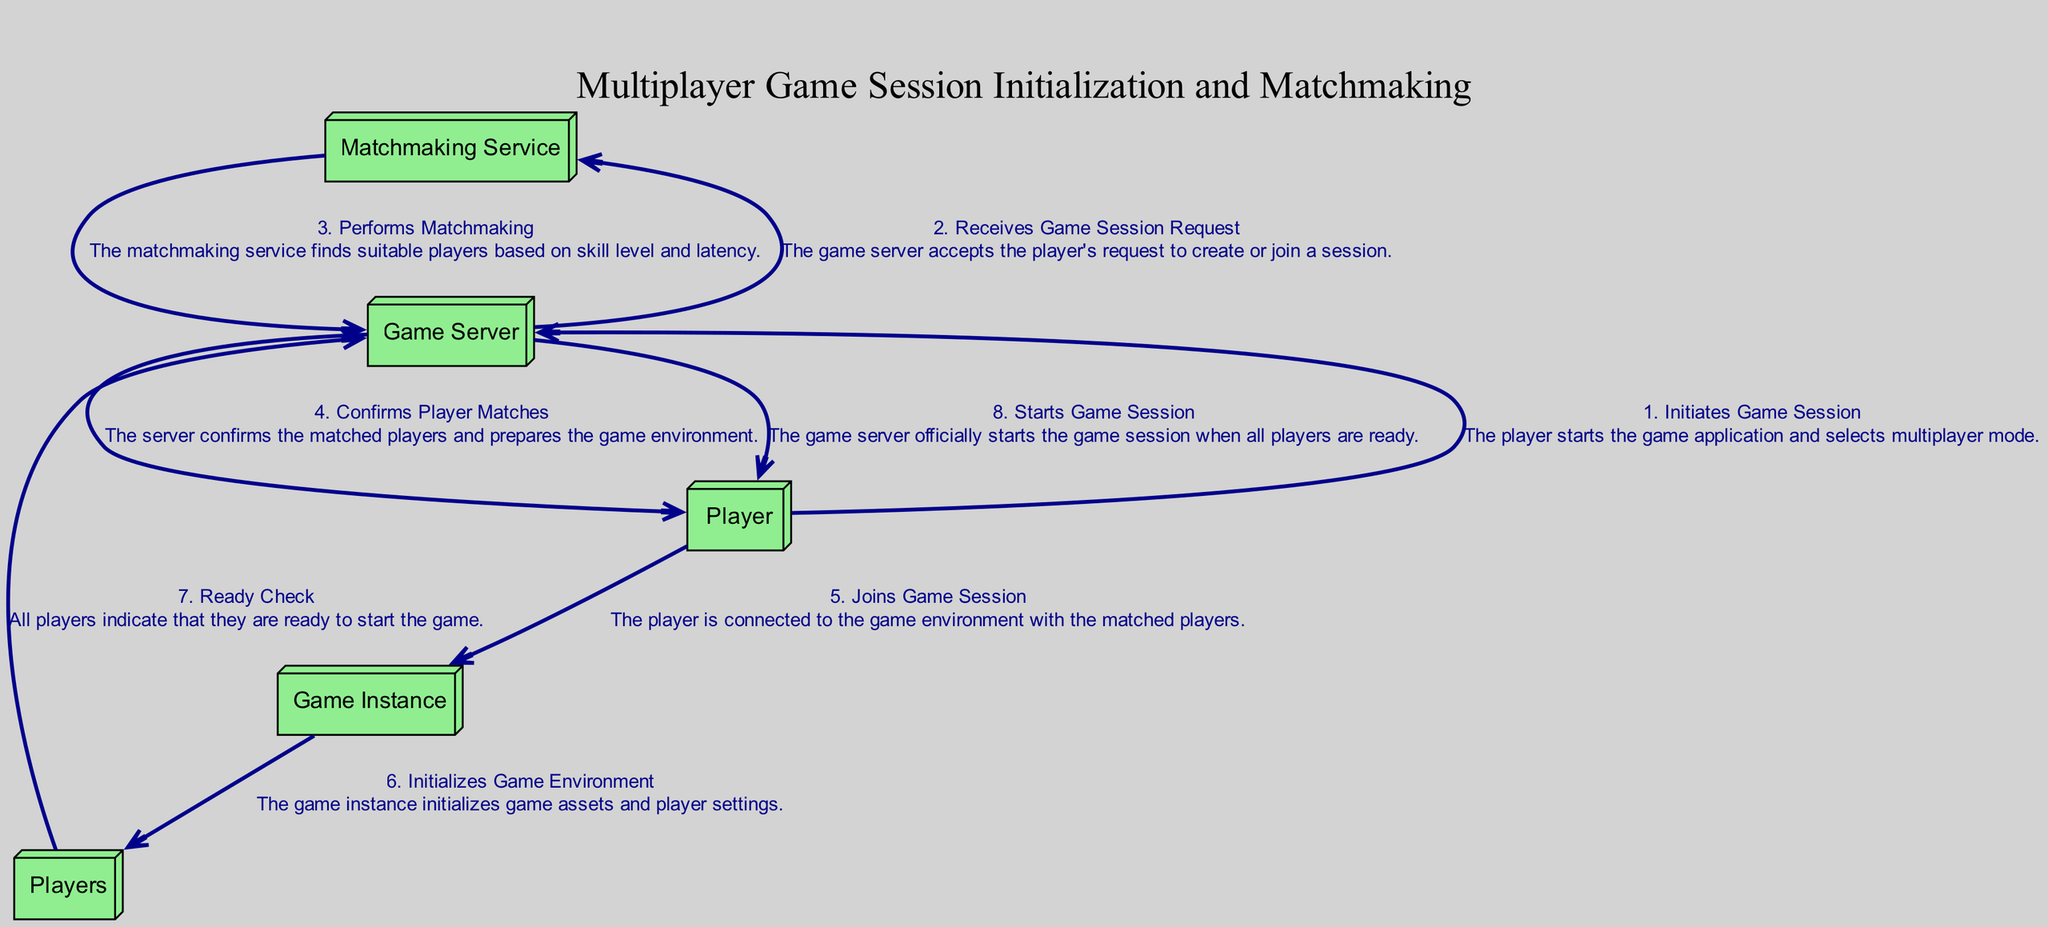What is the first action in the sequence? The sequence indicates that the first action is initiated by the Player, who starts the game application and selects multiplayer mode.
Answer: Initiates Game Session How many participants are involved in the sequence? The sequence identifies four distinct participants: Player, Game Server, Matchmaking Service, and Game Instance.
Answer: Four Which action follows the 'Receives Game Session Request'? After the game server receives the game session request, the next action is performed by the Matchmaking Service, which involves matchmaking the players.
Answer: Performs Matchmaking What action is taken by the Game Server after matchmaking? Following the matchmaking process, the Game Server confirms the player matches and prepares the game environment for the session.
Answer: Confirms Player Matches What is the final action in the sequence? The flow of events concludes with the Game Server officially starting the game session once all players indicate they are ready to play.
Answer: Starts Game Session Which participant performs the 'Ready Check'? The 'Ready Check' action involves all players indicating their readiness to start the game, and it's a collective action taken together by the Players.
Answer: Players What is the relationship between the 'Game Server' and 'Players' during the initialization? The relationship is that the Game Server facilitates the connection and preparation for the game session, while the Players interact with the server to join and indicate their readiness.
Answer: Facilitation How many total actions are depicted in the sequence? There are a total of eight distinct actions outlined in the sequence, from initiating the game session to starting it.
Answer: Eight What is the role of the Matchmaking Service in this sequence? The Matchmaking Service's role is to find suitable players based on their skill level and latency, facilitating a balanced gaming experience.
Answer: Performs Matchmaking 